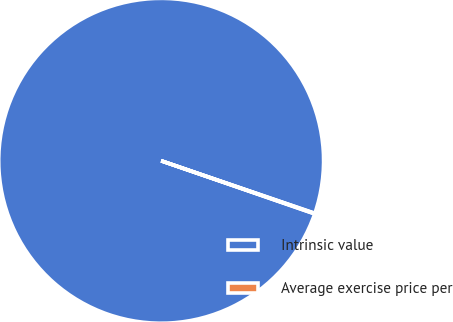Convert chart. <chart><loc_0><loc_0><loc_500><loc_500><pie_chart><fcel>Intrinsic value<fcel>Average exercise price per<nl><fcel>99.94%<fcel>0.06%<nl></chart> 